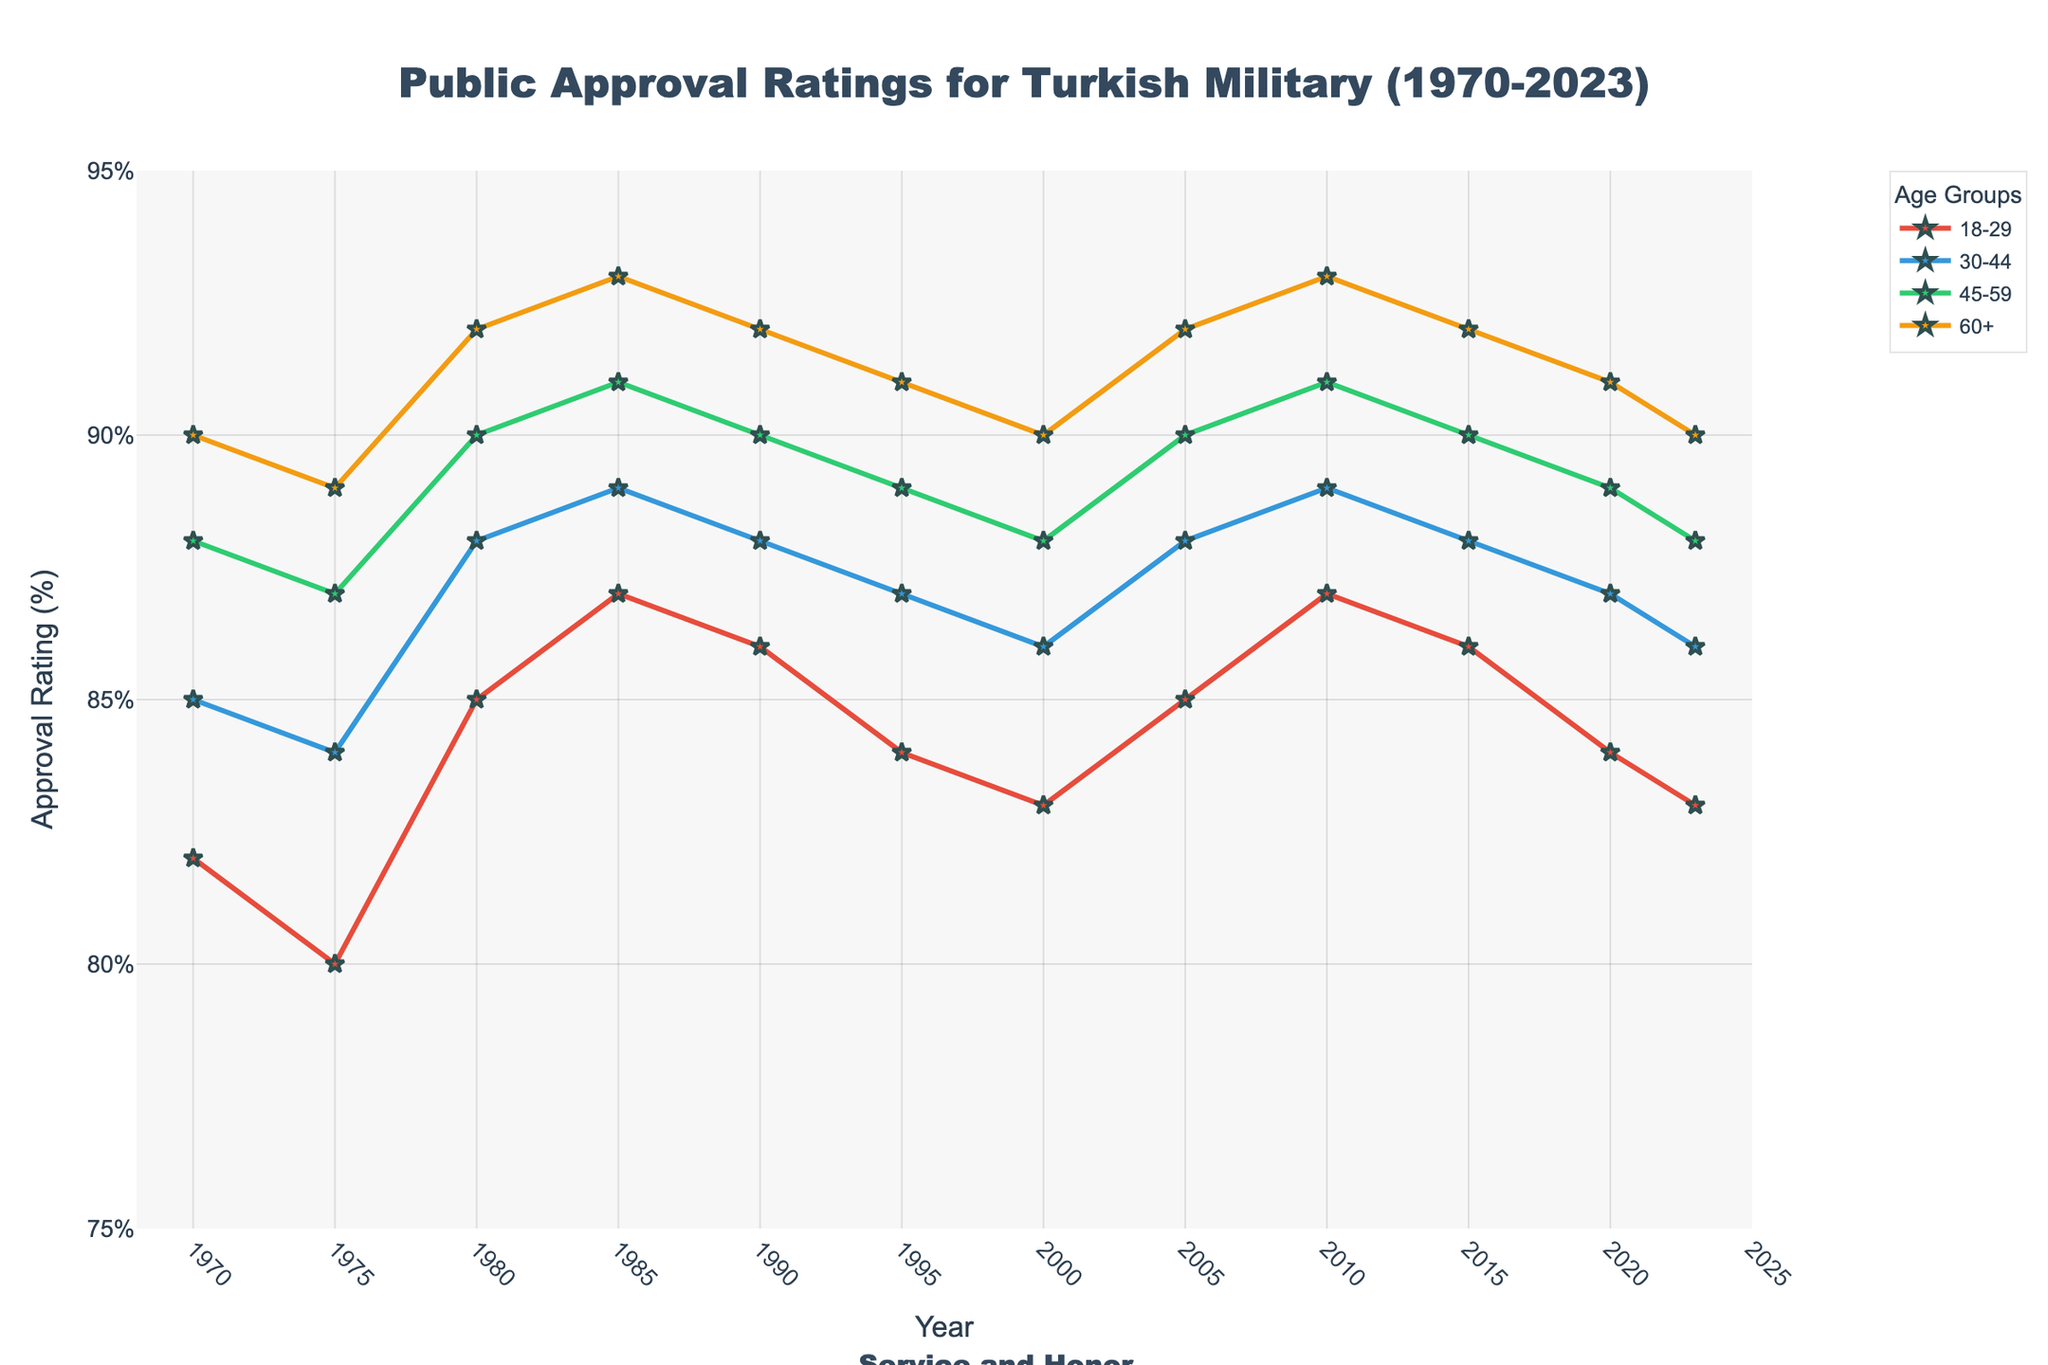What's the overall trend in approval ratings for the age group 18-29 from 1970 to 2023? The approval ratings for the age group 18-29 hover between 83% and 87% over the years, showing slight fluctuations but generally decreasing toward the end.
Answer: Slightly decreasing Which age group had the highest approval rating in 1980? In 1980, the approval ratings for the age groups are as follows: 18-29 (85%), 30-44 (88%), 45-59 (90%), and 60+ (92%). The 60+ age group had the highest rating.
Answer: 60+ How did the approval rating for the 45-59 age group change from 1990 to 2023? The approval rating for the 45-59 age group in 1990 was 90%, and it was 88% in 2023, indicating a decline of 2 percentage points.
Answer: Declined by 2% Which two age groups had the closest approval ratings in 2023? In 2023, the approval ratings are 18-29 (83%), 30-44 (86%), 45-59 (88%), and 60+ (90%). The smallest difference is between 30-44 (86%) and 45-59 (88%), a difference of 2 points.
Answer: 30-44 and 45-59 Did any age group show a consistent increase in approval ratings from 1970 to 2023? No age group showed a consistent increase from 1970 to 2023; all groups experienced periods of both increase and decrease.
Answer: No Which year showed the highest overall approval rating, considering all age groups? Each age group's highest rating is in 1980, with 18-29 (85%), 30-44 (88%), 45-59 (90%), and 60+ (92%), which suggests 1980 had the highest overall approval ratings.
Answer: 1980 What is the difference in approval ratings between the youngest (18-29) and oldest (60+) age groups in 2005? In 2005, the approval rating for the 18-29 age group is 85%, and for 60+ is 92%, leading to a difference of 7 percentage points.
Answer: 7 percentage points What's the average approval rating of the age group 30-44 over the entire period? The approval ratings for 30-44 are: 85, 84, 88, 89, 88, 87, 86, 88, 89, 88, 87, 86. The sum is 1045, and the average is 1045/12 ≈ 87.08%.
Answer: 87.08% Which age group had the biggest drop in approval ratings from its peak to its lowest point? The 18-29 age group had a peak of 87% (1985) and a low of 80% (1975), a drop of 7 percentage points. Other groups have smaller differences: 5% for 30-44, 3% for 45-59, and 3% for 60+.
Answer: 18-29 